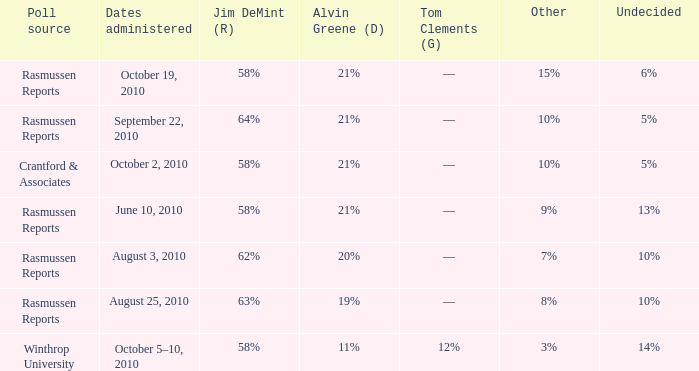What was the vote for Alvin Green when other was 9%? 21%. 